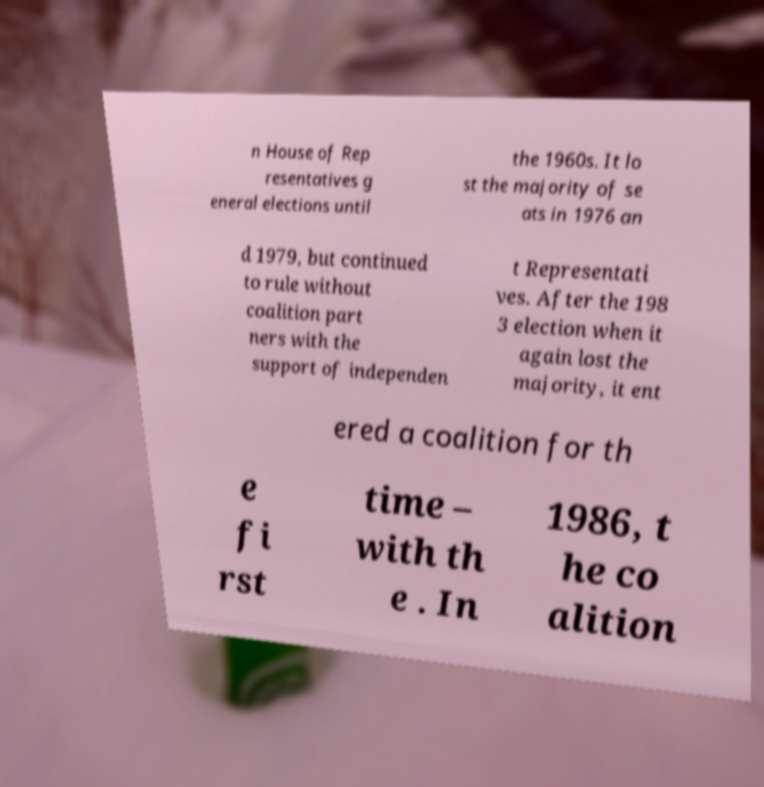Please identify and transcribe the text found in this image. n House of Rep resentatives g eneral elections until the 1960s. It lo st the majority of se ats in 1976 an d 1979, but continued to rule without coalition part ners with the support of independen t Representati ves. After the 198 3 election when it again lost the majority, it ent ered a coalition for th e fi rst time – with th e . In 1986, t he co alition 